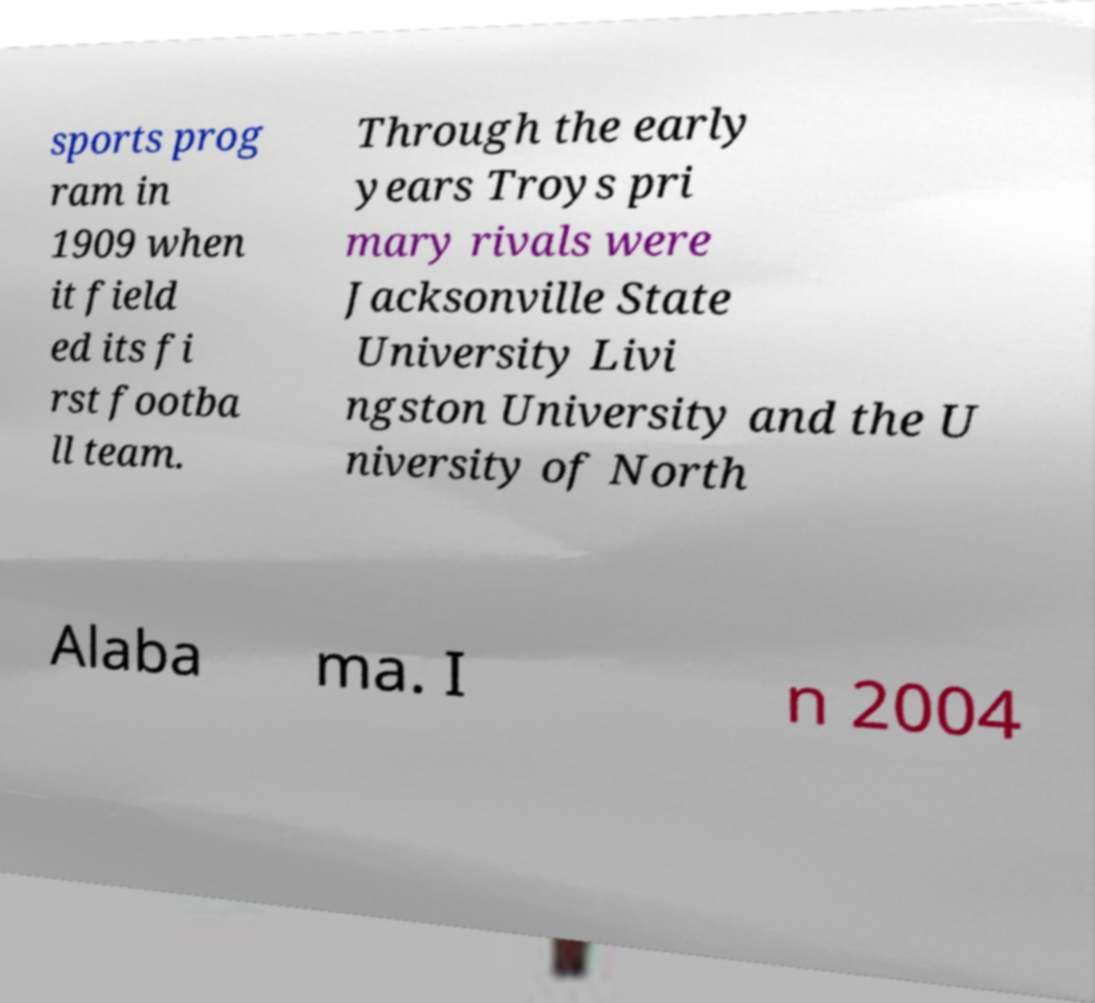What messages or text are displayed in this image? I need them in a readable, typed format. sports prog ram in 1909 when it field ed its fi rst footba ll team. Through the early years Troys pri mary rivals were Jacksonville State University Livi ngston University and the U niversity of North Alaba ma. I n 2004 